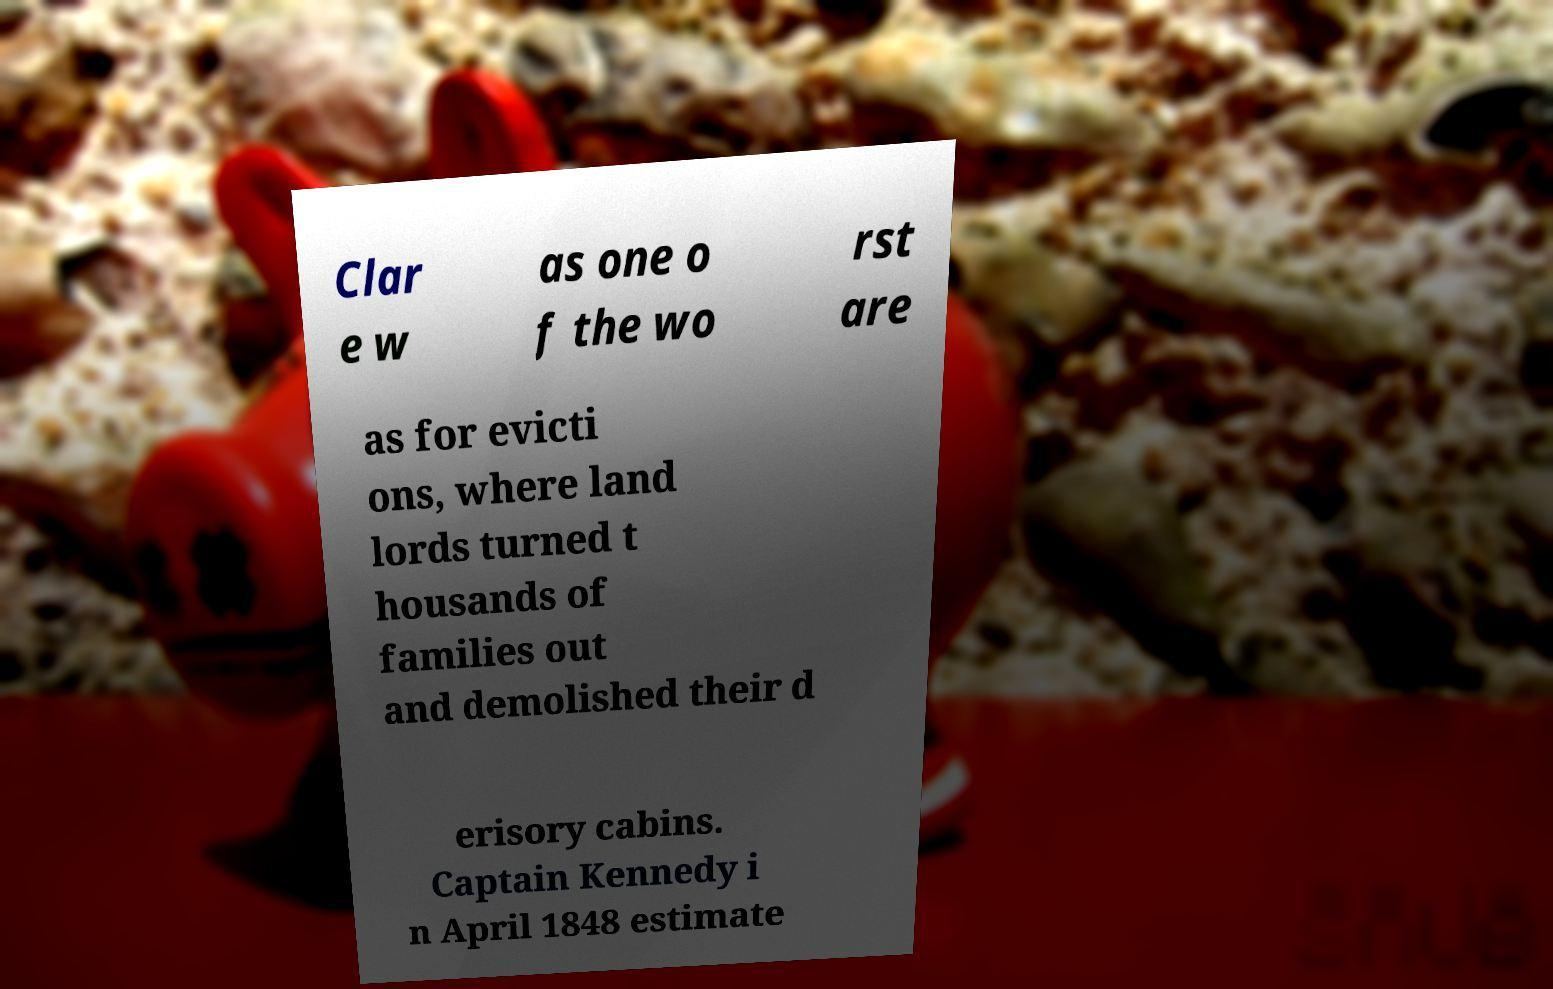Could you extract and type out the text from this image? Clar e w as one o f the wo rst are as for evicti ons, where land lords turned t housands of families out and demolished their d erisory cabins. Captain Kennedy i n April 1848 estimate 